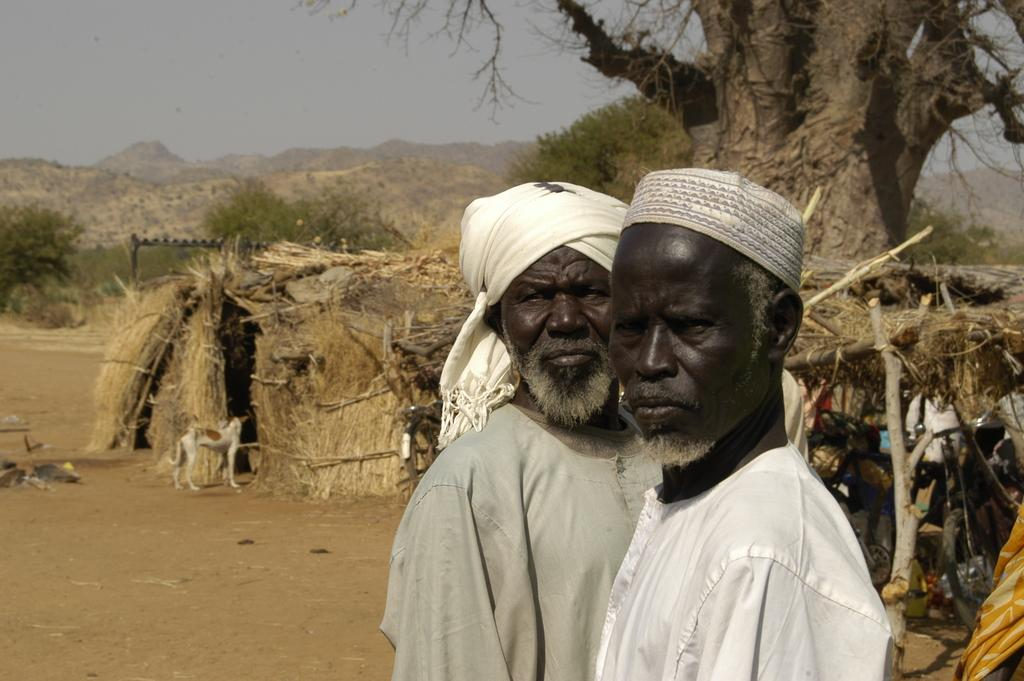How many people are in the image? There are two men in the image. What type of food can be seen in the image? There is a hot dog in the image. What natural elements are present in the image? There are trees and a mountain in the image. What part of the natural environment is visible in the background of the image? The sky is visible in the background of the image. What type of plastic material is being used by the men in the image? There is no plastic material visible in the image. What country are the men from in the image? The country of origin for the men cannot be determined from the image. 